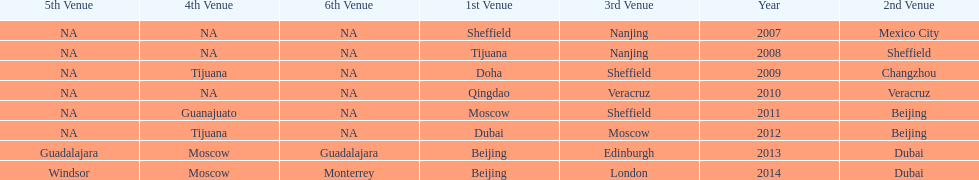In what year was the 3rd venue the same as 2011's 1st venue? 2012. 